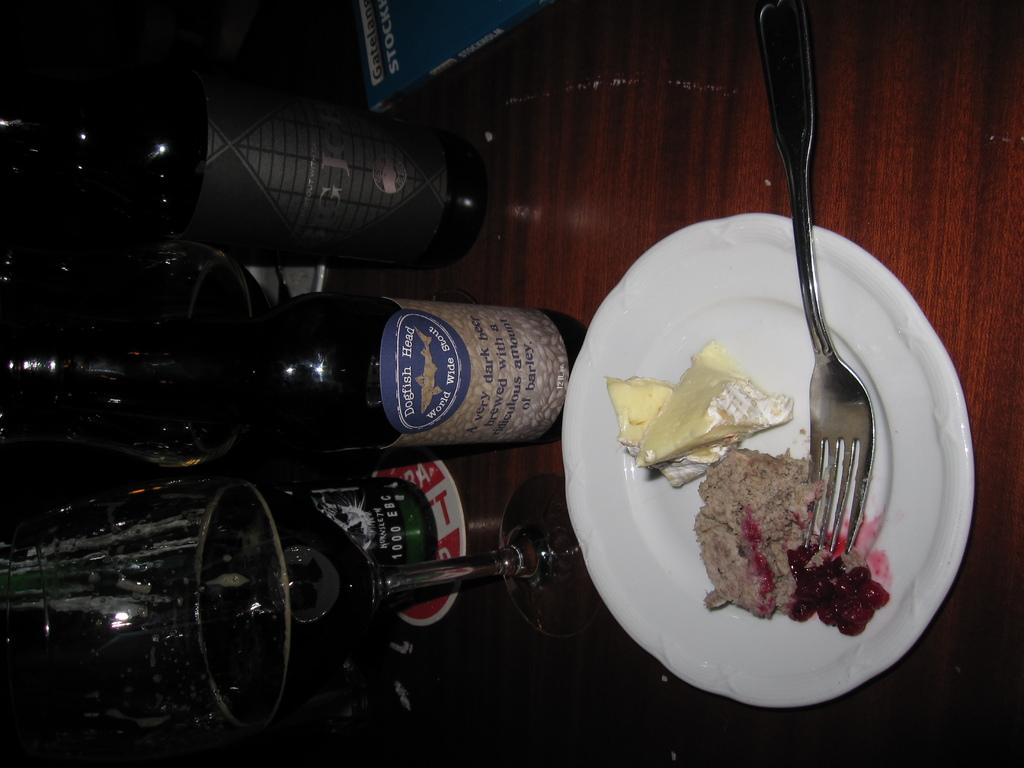What type of containers can be seen in the image? There are bottles in the image. What other objects can be seen in the image? There is a glass and a plate in the image. What is on the plate? There is food on the plate. On what surface are the objects placed? The objects are placed on a wooden table. What type of hill can be seen in the background of the image? There is no hill present in the image; it only features objects placed on a wooden table. 